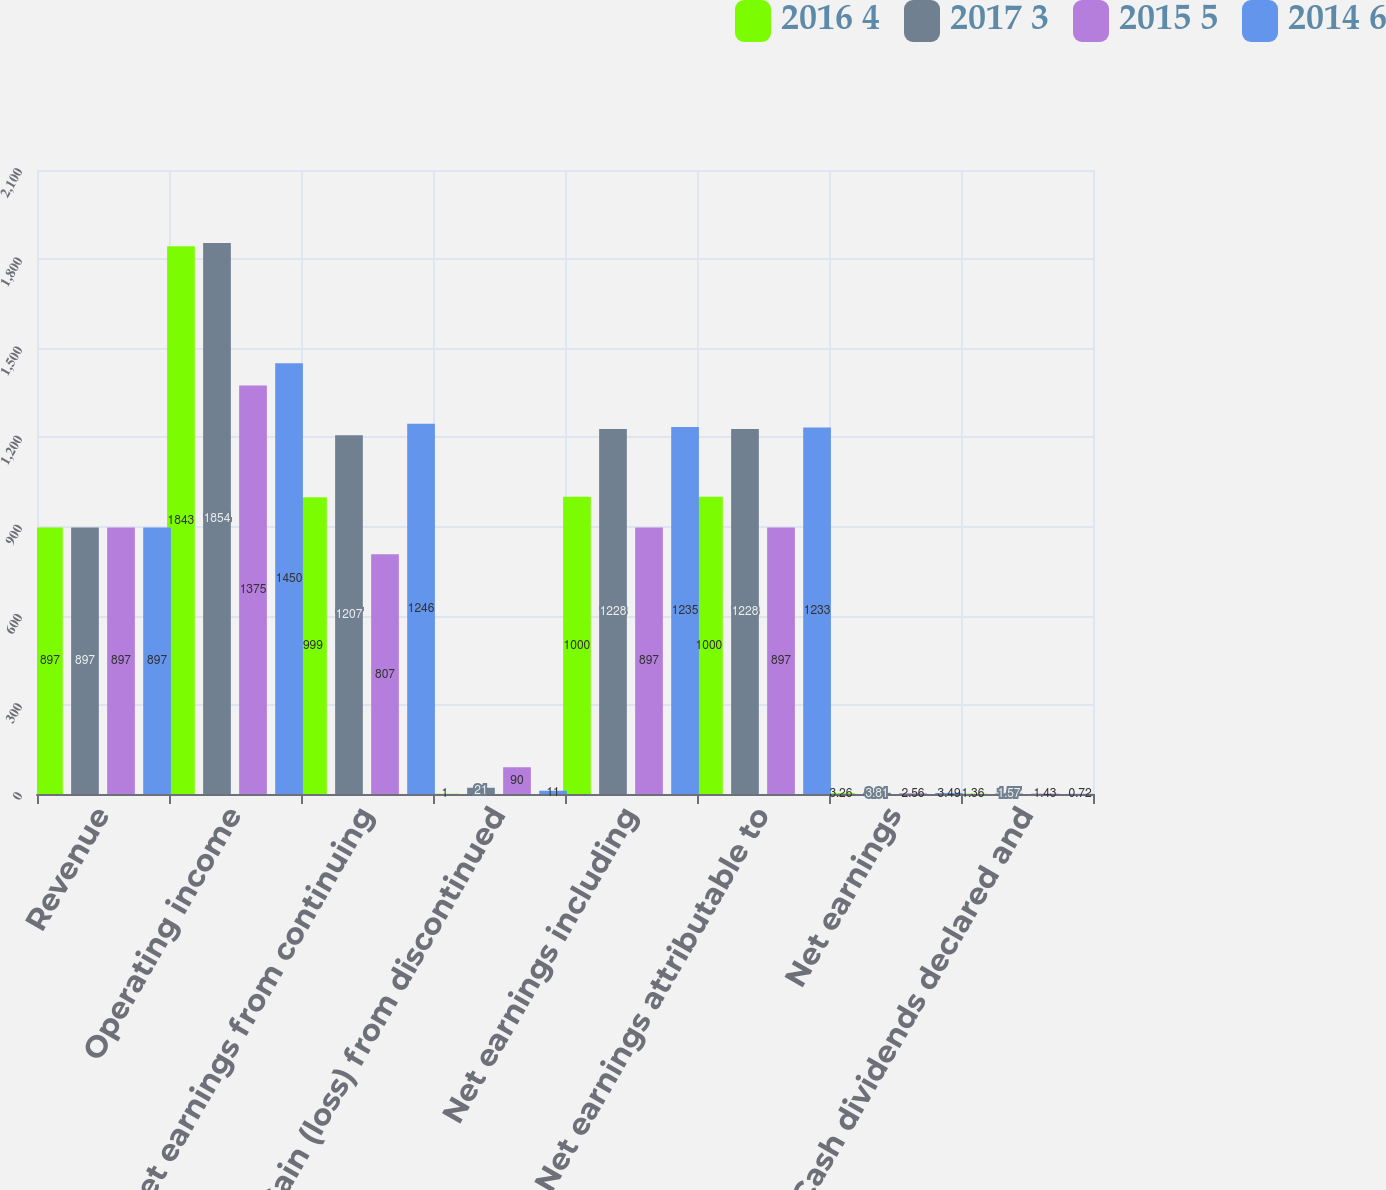<chart> <loc_0><loc_0><loc_500><loc_500><stacked_bar_chart><ecel><fcel>Revenue<fcel>Operating income<fcel>Net earnings from continuing<fcel>Gain (loss) from discontinued<fcel>Net earnings including<fcel>Net earnings attributable to<fcel>Net earnings<fcel>Cash dividends declared and<nl><fcel>2016 4<fcel>897<fcel>1843<fcel>999<fcel>1<fcel>1000<fcel>1000<fcel>3.26<fcel>1.36<nl><fcel>2017 3<fcel>897<fcel>1854<fcel>1207<fcel>21<fcel>1228<fcel>1228<fcel>3.81<fcel>1.57<nl><fcel>2015 5<fcel>897<fcel>1375<fcel>807<fcel>90<fcel>897<fcel>897<fcel>2.56<fcel>1.43<nl><fcel>2014 6<fcel>897<fcel>1450<fcel>1246<fcel>11<fcel>1235<fcel>1233<fcel>3.49<fcel>0.72<nl></chart> 